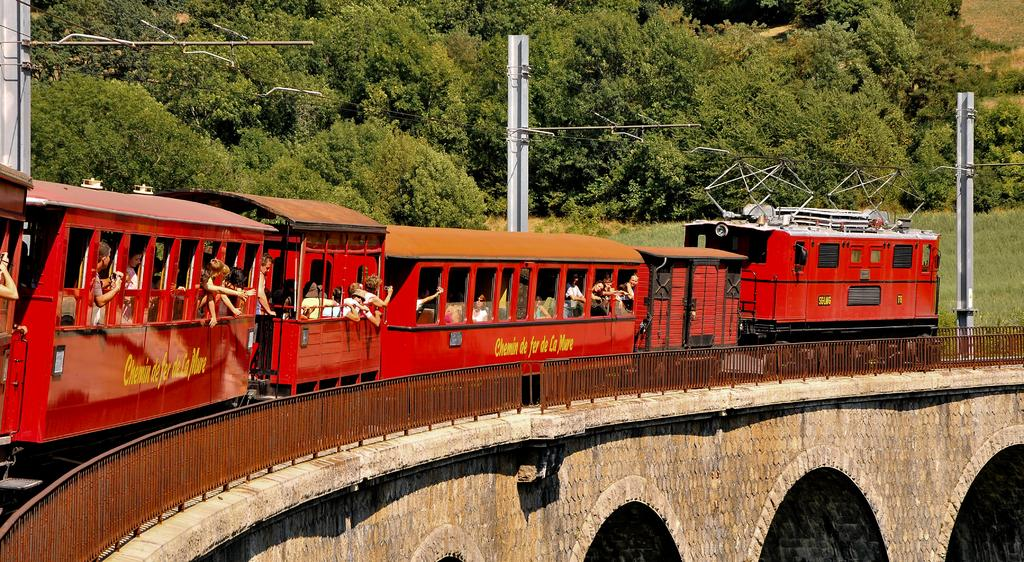What is the main subject of the image? The main subject of the image is a train. Where is the train located in the image? The train is on a bridge in the image. Can you describe the people inside the train? There are people inside the train, but their specific actions or appearances cannot be determined from the image. What type of infrastructure is present in the image? There are poles with cables and an iron pole fence in the image. What type of natural elements can be seen in the image? There are trees in the image. What type of cracker is being used to hold the train together in the image? There is no cracker present in the image, and the train does not require a cracker to hold it together. What type of vacation destination is visible in the image? There is no specific vacation destination visible in the image; it primarily features a train on a bridge. 